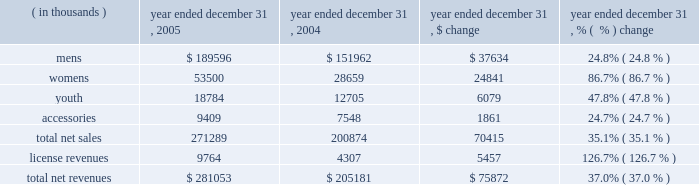Year ended december 31 , 2005 compared to year ended december 31 , 2004 net revenues increased $ 75.9 million , or 37.0% ( 37.0 % ) , to $ 281.1 million in 2005 from $ 205.2 million in 2004 .
This increase was the result of increases in both our net sales and license revenues as noted in the product category table below. .
Net sales increased $ 70.4 million , or 35.1% ( 35.1 % ) , to $ 271.3 million in 2005 from $ 200.9 million in 2004 as noted in the table above .
The increases in the mens , womens and youth product categories noted above primarily reflect : 2022 continued unit volume growth of our existing products sold to retail customers , while pricing of existing products remained relatively unchanged ; and 2022 new products introduced in 2005 accounted for $ 29.0 million of the increase in net sales which included the metal series , under armour tech-t line and our performance hooded sweatshirt for mens , womens and youth , and our new women 2019s duplicity sports bra .
License revenues increased $ 5.5 million to $ 9.8 million in 2005 from $ 4.3 million in 2004 .
This increase in license revenues was a result of increased sales by our licensees due to increased distribution , continued unit volume growth and new product offerings .
Gross profit increased $ 40.5 million to $ 135.9 million in 2005 from $ 95.4 million in 2004 .
Gross profit as a percentage of net revenues , or gross margin , increased 180 basis points to 48.3% ( 48.3 % ) in 2005 from 46.5% ( 46.5 % ) in 2004 .
This net increase in gross margin was primarily driven by the following : 2022 a 70 basis point increase due to the $ 5.5 million increase in license revenues ; 2022 a 240 basis point increase due to lower product costs as a result of greater supplier discounts for increased volume and lower cost sourcing arrangements ; 2022 a 50 basis point decrease driven by larger customer incentives , partially offset by more accurate demand forecasting and better inventory management ; and 2022 a 70 basis point decrease due to higher handling costs to make products to customer specifications for immediate display in their stores and higher overhead costs associated with our quick-turn , special make-up shop , which was instituted in june 2004 .
Selling , general and administrative expenses increased $ 29.9 million , or 42.7% ( 42.7 % ) , to $ 100.0 million in 2005 from $ 70.1 million in 2004 .
As a percentage of net revenues , selling , general and administrative expenses increased to 35.6% ( 35.6 % ) in 2005 from 34.1% ( 34.1 % ) in 2004 .
This net increase was primarily driven by the following : 2022 marketing costs increased $ 8.7 million to $ 30.5 million in 2005 from $ 21.8 million in 2004 .
The increase in these costs was due to increased advertising costs from our women 2019s media campaign , marketing salaries , and depreciation expense related to our in-store fixture program .
As a percentage of net revenues , marketing costs increased slightly to 10.9% ( 10.9 % ) in 2005 from 10.6% ( 10.6 % ) in 2004 due to the increased costs described above. .
In 2005 what was the percent of the mens revenues to the total net revenues? 
Computations: (189596 / 281053)
Answer: 0.67459. 